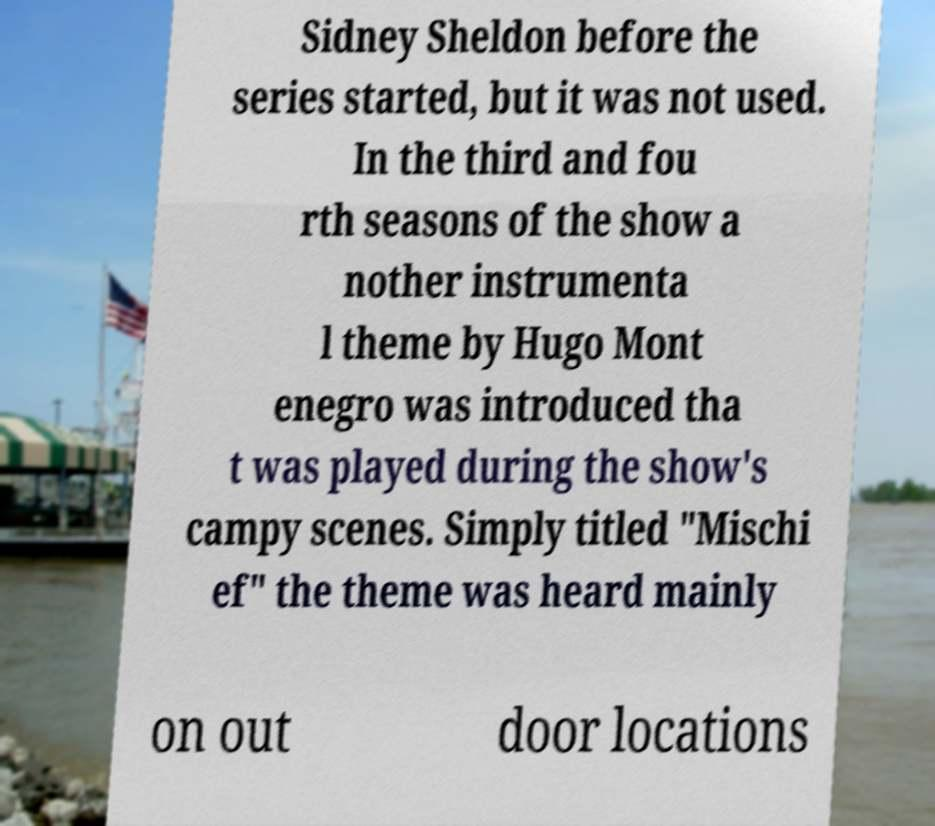Please read and relay the text visible in this image. What does it say? Sidney Sheldon before the series started, but it was not used. In the third and fou rth seasons of the show a nother instrumenta l theme by Hugo Mont enegro was introduced tha t was played during the show's campy scenes. Simply titled "Mischi ef" the theme was heard mainly on out door locations 